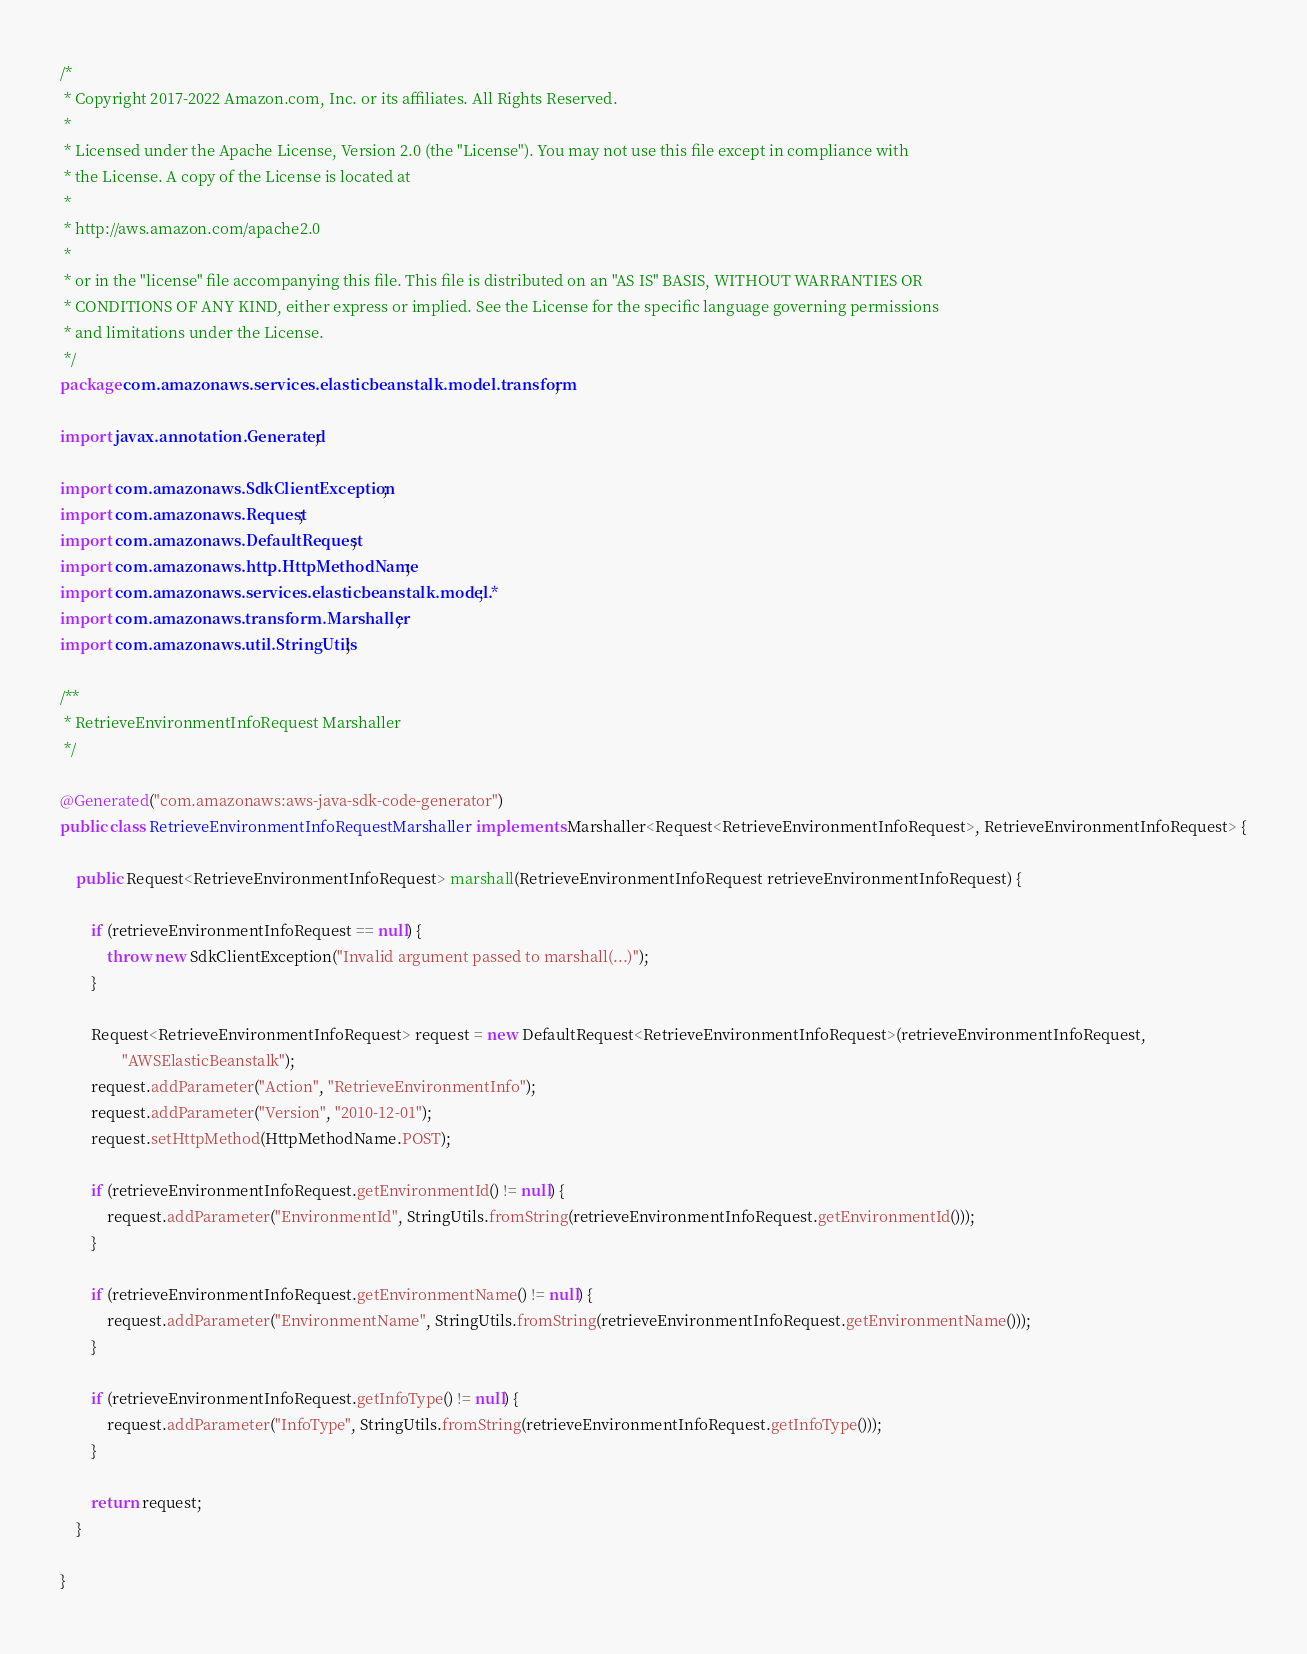<code> <loc_0><loc_0><loc_500><loc_500><_Java_>/*
 * Copyright 2017-2022 Amazon.com, Inc. or its affiliates. All Rights Reserved.
 * 
 * Licensed under the Apache License, Version 2.0 (the "License"). You may not use this file except in compliance with
 * the License. A copy of the License is located at
 * 
 * http://aws.amazon.com/apache2.0
 * 
 * or in the "license" file accompanying this file. This file is distributed on an "AS IS" BASIS, WITHOUT WARRANTIES OR
 * CONDITIONS OF ANY KIND, either express or implied. See the License for the specific language governing permissions
 * and limitations under the License.
 */
package com.amazonaws.services.elasticbeanstalk.model.transform;

import javax.annotation.Generated;

import com.amazonaws.SdkClientException;
import com.amazonaws.Request;
import com.amazonaws.DefaultRequest;
import com.amazonaws.http.HttpMethodName;
import com.amazonaws.services.elasticbeanstalk.model.*;
import com.amazonaws.transform.Marshaller;
import com.amazonaws.util.StringUtils;

/**
 * RetrieveEnvironmentInfoRequest Marshaller
 */

@Generated("com.amazonaws:aws-java-sdk-code-generator")
public class RetrieveEnvironmentInfoRequestMarshaller implements Marshaller<Request<RetrieveEnvironmentInfoRequest>, RetrieveEnvironmentInfoRequest> {

    public Request<RetrieveEnvironmentInfoRequest> marshall(RetrieveEnvironmentInfoRequest retrieveEnvironmentInfoRequest) {

        if (retrieveEnvironmentInfoRequest == null) {
            throw new SdkClientException("Invalid argument passed to marshall(...)");
        }

        Request<RetrieveEnvironmentInfoRequest> request = new DefaultRequest<RetrieveEnvironmentInfoRequest>(retrieveEnvironmentInfoRequest,
                "AWSElasticBeanstalk");
        request.addParameter("Action", "RetrieveEnvironmentInfo");
        request.addParameter("Version", "2010-12-01");
        request.setHttpMethod(HttpMethodName.POST);

        if (retrieveEnvironmentInfoRequest.getEnvironmentId() != null) {
            request.addParameter("EnvironmentId", StringUtils.fromString(retrieveEnvironmentInfoRequest.getEnvironmentId()));
        }

        if (retrieveEnvironmentInfoRequest.getEnvironmentName() != null) {
            request.addParameter("EnvironmentName", StringUtils.fromString(retrieveEnvironmentInfoRequest.getEnvironmentName()));
        }

        if (retrieveEnvironmentInfoRequest.getInfoType() != null) {
            request.addParameter("InfoType", StringUtils.fromString(retrieveEnvironmentInfoRequest.getInfoType()));
        }

        return request;
    }

}
</code> 